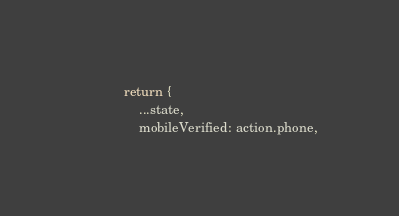Convert code to text. <code><loc_0><loc_0><loc_500><loc_500><_JavaScript_>            return {
                ...state,
                mobileVerified: action.phone,</code> 